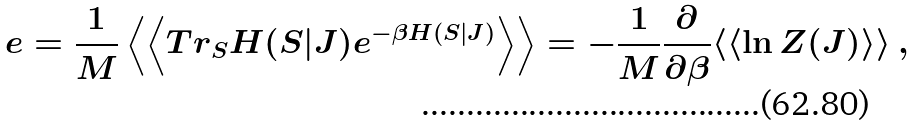<formula> <loc_0><loc_0><loc_500><loc_500>e & = \frac { 1 } { M } \left \langle \left \langle T r _ { S } H ( S | J ) e ^ { - \beta H ( S | J ) } \right \rangle \right \rangle = - \frac { 1 } { M } \frac { \partial } { \partial \beta } \langle \langle \ln Z ( J ) \rangle \rangle \ ,</formula> 